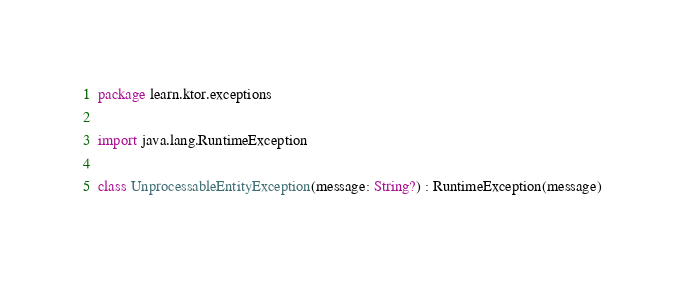Convert code to text. <code><loc_0><loc_0><loc_500><loc_500><_Kotlin_>package learn.ktor.exceptions

import java.lang.RuntimeException

class UnprocessableEntityException(message: String?) : RuntimeException(message)
</code> 